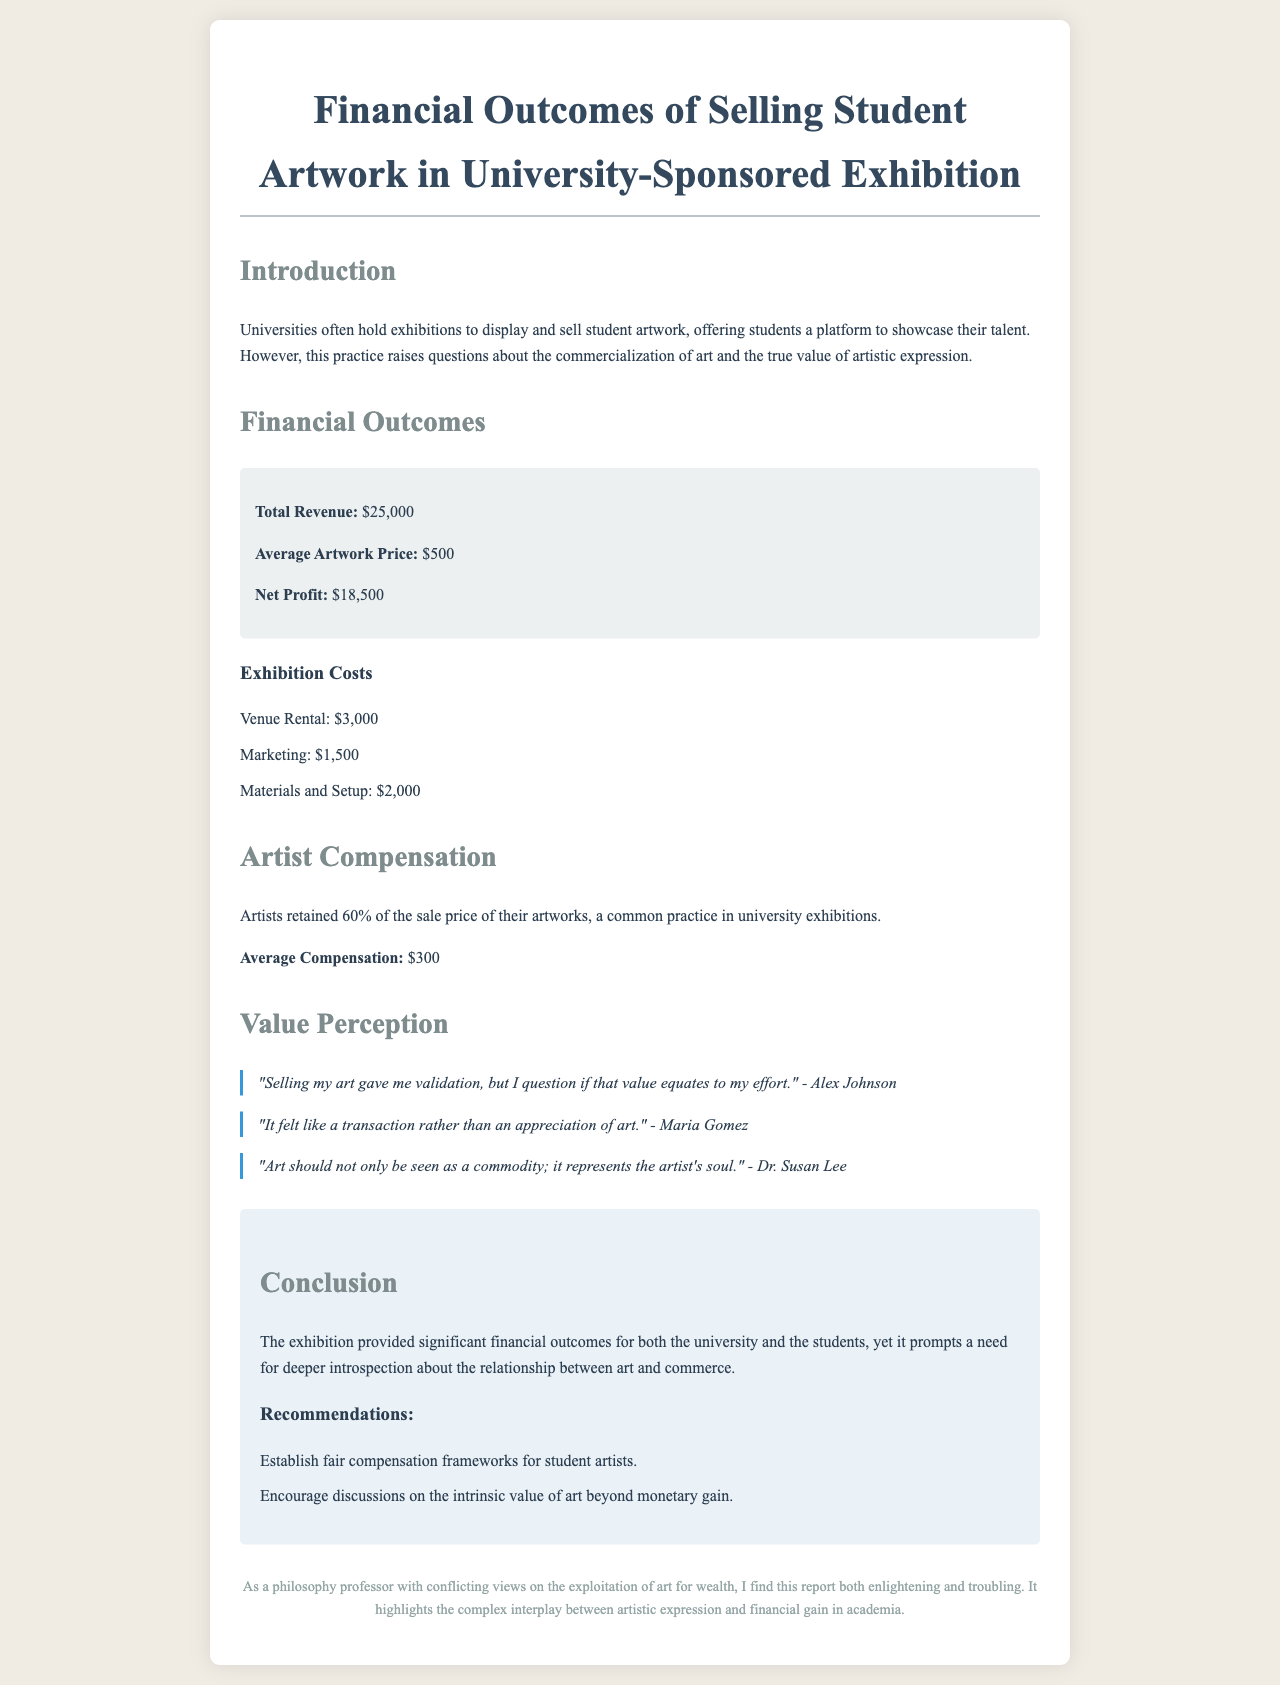what is the total revenue? The total revenue is specifically stated in the document as $25,000.
Answer: $25,000 what percentage of sale price do artists retain? The document mentions that artists retained 60% of the sale price.
Answer: 60% what are the exhibition costs for venue rental? Venue rental is listed as a specific cost in the expenses section of the document, which is $3,000.
Answer: $3,000 who is quoted as questioning the perception of their art after selling? The document includes a quote from Alex Johnson expressing their concerns about the value of their effort.
Answer: Alex Johnson what is the average artwork price? The average artwork price is indicated in the financial outcomes section and is $500.
Answer: $500 how much net profit was made from the exhibition? The net profit is provided as part of the financial outcomes, and it states $18,500.
Answer: $18,500 what is one of the recommendations given in the conclusion? The conclusion provides multiple recommendations, one being to establish fair compensation frameworks for student artists.
Answer: Establish fair compensation frameworks what is the average compensation for artists? The document states the average compensation as $300 in the artist compensation section.
Answer: $300 what type of feedback did artists give regarding the art selling experience? The document includes testimonials indicating mixed feelings, such as a transaction feeling rather than appreciation.
Answer: Mixed feelings 